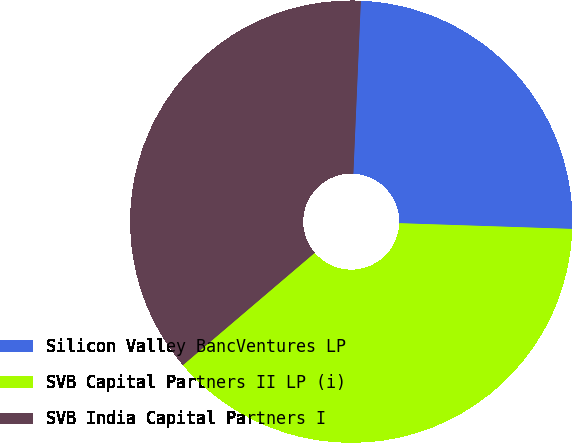Convert chart. <chart><loc_0><loc_0><loc_500><loc_500><pie_chart><fcel>Silicon Valley BancVentures LP<fcel>SVB Capital Partners II LP (i)<fcel>SVB India Capital Partners I<nl><fcel>24.84%<fcel>38.24%<fcel>36.92%<nl></chart> 